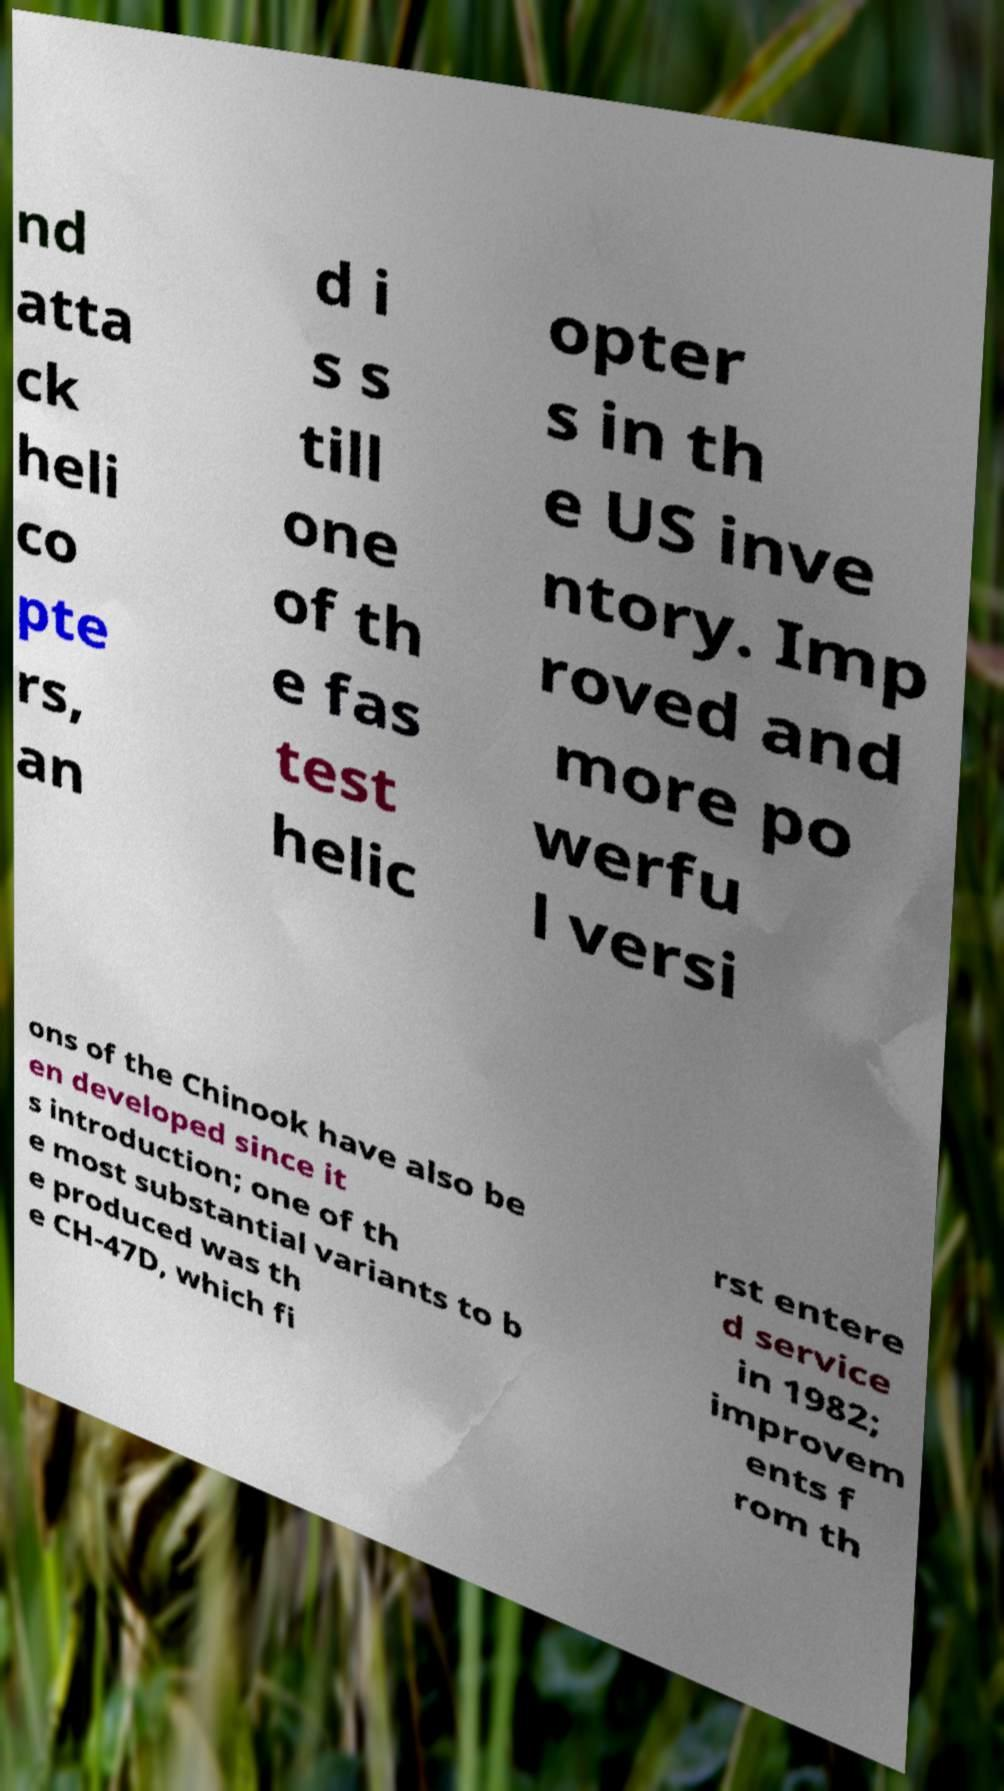Please identify and transcribe the text found in this image. nd atta ck heli co pte rs, an d i s s till one of th e fas test helic opter s in th e US inve ntory. Imp roved and more po werfu l versi ons of the Chinook have also be en developed since it s introduction; one of th e most substantial variants to b e produced was th e CH-47D, which fi rst entere d service in 1982; improvem ents f rom th 